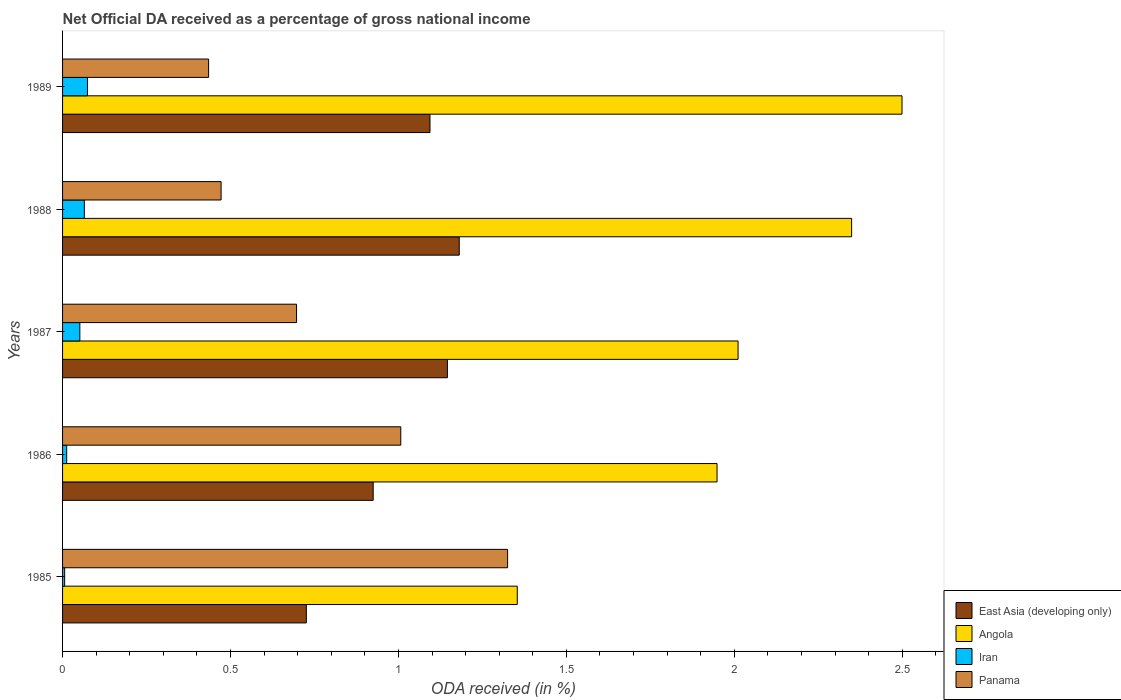How many different coloured bars are there?
Offer a very short reply. 4. Are the number of bars on each tick of the Y-axis equal?
Give a very brief answer. Yes. How many bars are there on the 5th tick from the top?
Your answer should be compact. 4. What is the net official DA received in East Asia (developing only) in 1987?
Your answer should be very brief. 1.15. Across all years, what is the maximum net official DA received in Iran?
Your answer should be very brief. 0.07. Across all years, what is the minimum net official DA received in Angola?
Offer a very short reply. 1.35. In which year was the net official DA received in Iran minimum?
Your answer should be compact. 1985. What is the total net official DA received in Iran in the graph?
Provide a succinct answer. 0.21. What is the difference between the net official DA received in Angola in 1985 and that in 1986?
Your answer should be very brief. -0.59. What is the difference between the net official DA received in East Asia (developing only) in 1987 and the net official DA received in Angola in 1985?
Offer a terse response. -0.21. What is the average net official DA received in Iran per year?
Give a very brief answer. 0.04. In the year 1986, what is the difference between the net official DA received in Panama and net official DA received in Iran?
Your answer should be very brief. 0.99. What is the ratio of the net official DA received in Iran in 1985 to that in 1988?
Ensure brevity in your answer.  0.1. Is the net official DA received in East Asia (developing only) in 1985 less than that in 1987?
Your answer should be very brief. Yes. What is the difference between the highest and the second highest net official DA received in East Asia (developing only)?
Ensure brevity in your answer.  0.04. What is the difference between the highest and the lowest net official DA received in Panama?
Make the answer very short. 0.89. Is the sum of the net official DA received in Iran in 1986 and 1987 greater than the maximum net official DA received in Panama across all years?
Your response must be concise. No. What does the 2nd bar from the top in 1987 represents?
Offer a very short reply. Iran. What does the 3rd bar from the bottom in 1988 represents?
Make the answer very short. Iran. How many years are there in the graph?
Your response must be concise. 5. What is the difference between two consecutive major ticks on the X-axis?
Provide a short and direct response. 0.5. Does the graph contain grids?
Offer a terse response. No. What is the title of the graph?
Your answer should be compact. Net Official DA received as a percentage of gross national income. What is the label or title of the X-axis?
Keep it short and to the point. ODA received (in %). What is the ODA received (in %) in East Asia (developing only) in 1985?
Your response must be concise. 0.73. What is the ODA received (in %) in Angola in 1985?
Your answer should be very brief. 1.35. What is the ODA received (in %) in Iran in 1985?
Give a very brief answer. 0.01. What is the ODA received (in %) of Panama in 1985?
Make the answer very short. 1.32. What is the ODA received (in %) in East Asia (developing only) in 1986?
Give a very brief answer. 0.92. What is the ODA received (in %) in Angola in 1986?
Offer a terse response. 1.95. What is the ODA received (in %) of Iran in 1986?
Provide a short and direct response. 0.01. What is the ODA received (in %) in Panama in 1986?
Offer a very short reply. 1.01. What is the ODA received (in %) of East Asia (developing only) in 1987?
Ensure brevity in your answer.  1.15. What is the ODA received (in %) of Angola in 1987?
Make the answer very short. 2.01. What is the ODA received (in %) in Iran in 1987?
Provide a succinct answer. 0.05. What is the ODA received (in %) of Panama in 1987?
Offer a very short reply. 0.7. What is the ODA received (in %) in East Asia (developing only) in 1988?
Keep it short and to the point. 1.18. What is the ODA received (in %) in Angola in 1988?
Make the answer very short. 2.35. What is the ODA received (in %) in Iran in 1988?
Offer a very short reply. 0.06. What is the ODA received (in %) of Panama in 1988?
Provide a succinct answer. 0.47. What is the ODA received (in %) in East Asia (developing only) in 1989?
Give a very brief answer. 1.09. What is the ODA received (in %) of Angola in 1989?
Your response must be concise. 2.5. What is the ODA received (in %) of Iran in 1989?
Offer a very short reply. 0.07. What is the ODA received (in %) of Panama in 1989?
Your response must be concise. 0.43. Across all years, what is the maximum ODA received (in %) of East Asia (developing only)?
Offer a terse response. 1.18. Across all years, what is the maximum ODA received (in %) of Angola?
Offer a very short reply. 2.5. Across all years, what is the maximum ODA received (in %) in Iran?
Ensure brevity in your answer.  0.07. Across all years, what is the maximum ODA received (in %) in Panama?
Offer a terse response. 1.32. Across all years, what is the minimum ODA received (in %) of East Asia (developing only)?
Offer a very short reply. 0.73. Across all years, what is the minimum ODA received (in %) in Angola?
Make the answer very short. 1.35. Across all years, what is the minimum ODA received (in %) in Iran?
Offer a very short reply. 0.01. Across all years, what is the minimum ODA received (in %) in Panama?
Provide a succinct answer. 0.43. What is the total ODA received (in %) in East Asia (developing only) in the graph?
Provide a succinct answer. 5.07. What is the total ODA received (in %) in Angola in the graph?
Your answer should be compact. 10.16. What is the total ODA received (in %) in Iran in the graph?
Provide a short and direct response. 0.21. What is the total ODA received (in %) in Panama in the graph?
Your answer should be very brief. 3.94. What is the difference between the ODA received (in %) in East Asia (developing only) in 1985 and that in 1986?
Give a very brief answer. -0.2. What is the difference between the ODA received (in %) in Angola in 1985 and that in 1986?
Offer a terse response. -0.59. What is the difference between the ODA received (in %) of Iran in 1985 and that in 1986?
Your answer should be very brief. -0.01. What is the difference between the ODA received (in %) in Panama in 1985 and that in 1986?
Make the answer very short. 0.32. What is the difference between the ODA received (in %) in East Asia (developing only) in 1985 and that in 1987?
Your answer should be very brief. -0.42. What is the difference between the ODA received (in %) in Angola in 1985 and that in 1987?
Keep it short and to the point. -0.66. What is the difference between the ODA received (in %) of Iran in 1985 and that in 1987?
Offer a very short reply. -0.05. What is the difference between the ODA received (in %) in Panama in 1985 and that in 1987?
Give a very brief answer. 0.63. What is the difference between the ODA received (in %) of East Asia (developing only) in 1985 and that in 1988?
Give a very brief answer. -0.46. What is the difference between the ODA received (in %) of Angola in 1985 and that in 1988?
Keep it short and to the point. -1. What is the difference between the ODA received (in %) in Iran in 1985 and that in 1988?
Provide a short and direct response. -0.06. What is the difference between the ODA received (in %) in Panama in 1985 and that in 1988?
Your answer should be compact. 0.85. What is the difference between the ODA received (in %) in East Asia (developing only) in 1985 and that in 1989?
Make the answer very short. -0.37. What is the difference between the ODA received (in %) of Angola in 1985 and that in 1989?
Provide a succinct answer. -1.15. What is the difference between the ODA received (in %) of Iran in 1985 and that in 1989?
Keep it short and to the point. -0.07. What is the difference between the ODA received (in %) of Panama in 1985 and that in 1989?
Provide a short and direct response. 0.89. What is the difference between the ODA received (in %) of East Asia (developing only) in 1986 and that in 1987?
Offer a very short reply. -0.22. What is the difference between the ODA received (in %) of Angola in 1986 and that in 1987?
Provide a succinct answer. -0.06. What is the difference between the ODA received (in %) in Iran in 1986 and that in 1987?
Make the answer very short. -0.04. What is the difference between the ODA received (in %) in Panama in 1986 and that in 1987?
Your answer should be very brief. 0.31. What is the difference between the ODA received (in %) of East Asia (developing only) in 1986 and that in 1988?
Offer a terse response. -0.26. What is the difference between the ODA received (in %) of Angola in 1986 and that in 1988?
Provide a succinct answer. -0.4. What is the difference between the ODA received (in %) in Iran in 1986 and that in 1988?
Keep it short and to the point. -0.05. What is the difference between the ODA received (in %) of Panama in 1986 and that in 1988?
Your answer should be compact. 0.53. What is the difference between the ODA received (in %) in East Asia (developing only) in 1986 and that in 1989?
Your answer should be compact. -0.17. What is the difference between the ODA received (in %) of Angola in 1986 and that in 1989?
Offer a very short reply. -0.55. What is the difference between the ODA received (in %) in Iran in 1986 and that in 1989?
Ensure brevity in your answer.  -0.06. What is the difference between the ODA received (in %) of Panama in 1986 and that in 1989?
Offer a terse response. 0.57. What is the difference between the ODA received (in %) in East Asia (developing only) in 1987 and that in 1988?
Ensure brevity in your answer.  -0.04. What is the difference between the ODA received (in %) in Angola in 1987 and that in 1988?
Your response must be concise. -0.34. What is the difference between the ODA received (in %) of Iran in 1987 and that in 1988?
Provide a short and direct response. -0.01. What is the difference between the ODA received (in %) in Panama in 1987 and that in 1988?
Your answer should be very brief. 0.22. What is the difference between the ODA received (in %) of East Asia (developing only) in 1987 and that in 1989?
Offer a very short reply. 0.05. What is the difference between the ODA received (in %) in Angola in 1987 and that in 1989?
Your answer should be very brief. -0.49. What is the difference between the ODA received (in %) in Iran in 1987 and that in 1989?
Your answer should be very brief. -0.02. What is the difference between the ODA received (in %) in Panama in 1987 and that in 1989?
Give a very brief answer. 0.26. What is the difference between the ODA received (in %) in East Asia (developing only) in 1988 and that in 1989?
Offer a very short reply. 0.09. What is the difference between the ODA received (in %) in Iran in 1988 and that in 1989?
Offer a terse response. -0.01. What is the difference between the ODA received (in %) in Panama in 1988 and that in 1989?
Offer a terse response. 0.04. What is the difference between the ODA received (in %) of East Asia (developing only) in 1985 and the ODA received (in %) of Angola in 1986?
Offer a very short reply. -1.22. What is the difference between the ODA received (in %) in East Asia (developing only) in 1985 and the ODA received (in %) in Iran in 1986?
Offer a terse response. 0.71. What is the difference between the ODA received (in %) of East Asia (developing only) in 1985 and the ODA received (in %) of Panama in 1986?
Your answer should be compact. -0.28. What is the difference between the ODA received (in %) of Angola in 1985 and the ODA received (in %) of Iran in 1986?
Make the answer very short. 1.34. What is the difference between the ODA received (in %) in Angola in 1985 and the ODA received (in %) in Panama in 1986?
Give a very brief answer. 0.35. What is the difference between the ODA received (in %) in Iran in 1985 and the ODA received (in %) in Panama in 1986?
Give a very brief answer. -1. What is the difference between the ODA received (in %) of East Asia (developing only) in 1985 and the ODA received (in %) of Angola in 1987?
Give a very brief answer. -1.29. What is the difference between the ODA received (in %) in East Asia (developing only) in 1985 and the ODA received (in %) in Iran in 1987?
Provide a succinct answer. 0.67. What is the difference between the ODA received (in %) in East Asia (developing only) in 1985 and the ODA received (in %) in Panama in 1987?
Offer a terse response. 0.03. What is the difference between the ODA received (in %) of Angola in 1985 and the ODA received (in %) of Iran in 1987?
Give a very brief answer. 1.3. What is the difference between the ODA received (in %) in Angola in 1985 and the ODA received (in %) in Panama in 1987?
Your response must be concise. 0.66. What is the difference between the ODA received (in %) in Iran in 1985 and the ODA received (in %) in Panama in 1987?
Give a very brief answer. -0.69. What is the difference between the ODA received (in %) in East Asia (developing only) in 1985 and the ODA received (in %) in Angola in 1988?
Your response must be concise. -1.62. What is the difference between the ODA received (in %) of East Asia (developing only) in 1985 and the ODA received (in %) of Iran in 1988?
Provide a succinct answer. 0.66. What is the difference between the ODA received (in %) in East Asia (developing only) in 1985 and the ODA received (in %) in Panama in 1988?
Your answer should be very brief. 0.25. What is the difference between the ODA received (in %) in Angola in 1985 and the ODA received (in %) in Iran in 1988?
Make the answer very short. 1.29. What is the difference between the ODA received (in %) of Angola in 1985 and the ODA received (in %) of Panama in 1988?
Offer a very short reply. 0.88. What is the difference between the ODA received (in %) in Iran in 1985 and the ODA received (in %) in Panama in 1988?
Provide a succinct answer. -0.47. What is the difference between the ODA received (in %) in East Asia (developing only) in 1985 and the ODA received (in %) in Angola in 1989?
Your answer should be very brief. -1.77. What is the difference between the ODA received (in %) of East Asia (developing only) in 1985 and the ODA received (in %) of Iran in 1989?
Offer a terse response. 0.65. What is the difference between the ODA received (in %) in East Asia (developing only) in 1985 and the ODA received (in %) in Panama in 1989?
Offer a terse response. 0.29. What is the difference between the ODA received (in %) in Angola in 1985 and the ODA received (in %) in Iran in 1989?
Offer a terse response. 1.28. What is the difference between the ODA received (in %) in Angola in 1985 and the ODA received (in %) in Panama in 1989?
Your response must be concise. 0.92. What is the difference between the ODA received (in %) of Iran in 1985 and the ODA received (in %) of Panama in 1989?
Offer a very short reply. -0.43. What is the difference between the ODA received (in %) of East Asia (developing only) in 1986 and the ODA received (in %) of Angola in 1987?
Offer a terse response. -1.09. What is the difference between the ODA received (in %) of East Asia (developing only) in 1986 and the ODA received (in %) of Iran in 1987?
Your response must be concise. 0.87. What is the difference between the ODA received (in %) in East Asia (developing only) in 1986 and the ODA received (in %) in Panama in 1987?
Ensure brevity in your answer.  0.23. What is the difference between the ODA received (in %) of Angola in 1986 and the ODA received (in %) of Iran in 1987?
Provide a short and direct response. 1.9. What is the difference between the ODA received (in %) of Angola in 1986 and the ODA received (in %) of Panama in 1987?
Keep it short and to the point. 1.25. What is the difference between the ODA received (in %) of Iran in 1986 and the ODA received (in %) of Panama in 1987?
Your answer should be compact. -0.68. What is the difference between the ODA received (in %) of East Asia (developing only) in 1986 and the ODA received (in %) of Angola in 1988?
Keep it short and to the point. -1.42. What is the difference between the ODA received (in %) in East Asia (developing only) in 1986 and the ODA received (in %) in Iran in 1988?
Your response must be concise. 0.86. What is the difference between the ODA received (in %) in East Asia (developing only) in 1986 and the ODA received (in %) in Panama in 1988?
Your answer should be compact. 0.45. What is the difference between the ODA received (in %) of Angola in 1986 and the ODA received (in %) of Iran in 1988?
Make the answer very short. 1.88. What is the difference between the ODA received (in %) of Angola in 1986 and the ODA received (in %) of Panama in 1988?
Offer a terse response. 1.48. What is the difference between the ODA received (in %) of Iran in 1986 and the ODA received (in %) of Panama in 1988?
Give a very brief answer. -0.46. What is the difference between the ODA received (in %) of East Asia (developing only) in 1986 and the ODA received (in %) of Angola in 1989?
Your response must be concise. -1.57. What is the difference between the ODA received (in %) of East Asia (developing only) in 1986 and the ODA received (in %) of Iran in 1989?
Offer a terse response. 0.85. What is the difference between the ODA received (in %) in East Asia (developing only) in 1986 and the ODA received (in %) in Panama in 1989?
Give a very brief answer. 0.49. What is the difference between the ODA received (in %) of Angola in 1986 and the ODA received (in %) of Iran in 1989?
Offer a very short reply. 1.87. What is the difference between the ODA received (in %) of Angola in 1986 and the ODA received (in %) of Panama in 1989?
Your answer should be compact. 1.51. What is the difference between the ODA received (in %) of Iran in 1986 and the ODA received (in %) of Panama in 1989?
Give a very brief answer. -0.42. What is the difference between the ODA received (in %) in East Asia (developing only) in 1987 and the ODA received (in %) in Angola in 1988?
Your answer should be compact. -1.2. What is the difference between the ODA received (in %) of East Asia (developing only) in 1987 and the ODA received (in %) of Iran in 1988?
Your response must be concise. 1.08. What is the difference between the ODA received (in %) in East Asia (developing only) in 1987 and the ODA received (in %) in Panama in 1988?
Your response must be concise. 0.67. What is the difference between the ODA received (in %) in Angola in 1987 and the ODA received (in %) in Iran in 1988?
Provide a short and direct response. 1.95. What is the difference between the ODA received (in %) of Angola in 1987 and the ODA received (in %) of Panama in 1988?
Provide a succinct answer. 1.54. What is the difference between the ODA received (in %) in Iran in 1987 and the ODA received (in %) in Panama in 1988?
Provide a short and direct response. -0.42. What is the difference between the ODA received (in %) of East Asia (developing only) in 1987 and the ODA received (in %) of Angola in 1989?
Provide a short and direct response. -1.35. What is the difference between the ODA received (in %) in East Asia (developing only) in 1987 and the ODA received (in %) in Iran in 1989?
Provide a short and direct response. 1.07. What is the difference between the ODA received (in %) in East Asia (developing only) in 1987 and the ODA received (in %) in Panama in 1989?
Offer a terse response. 0.71. What is the difference between the ODA received (in %) of Angola in 1987 and the ODA received (in %) of Iran in 1989?
Provide a succinct answer. 1.94. What is the difference between the ODA received (in %) in Angola in 1987 and the ODA received (in %) in Panama in 1989?
Offer a very short reply. 1.58. What is the difference between the ODA received (in %) of Iran in 1987 and the ODA received (in %) of Panama in 1989?
Ensure brevity in your answer.  -0.38. What is the difference between the ODA received (in %) in East Asia (developing only) in 1988 and the ODA received (in %) in Angola in 1989?
Your answer should be very brief. -1.32. What is the difference between the ODA received (in %) of East Asia (developing only) in 1988 and the ODA received (in %) of Iran in 1989?
Make the answer very short. 1.11. What is the difference between the ODA received (in %) in East Asia (developing only) in 1988 and the ODA received (in %) in Panama in 1989?
Provide a succinct answer. 0.75. What is the difference between the ODA received (in %) of Angola in 1988 and the ODA received (in %) of Iran in 1989?
Give a very brief answer. 2.27. What is the difference between the ODA received (in %) of Angola in 1988 and the ODA received (in %) of Panama in 1989?
Ensure brevity in your answer.  1.91. What is the difference between the ODA received (in %) of Iran in 1988 and the ODA received (in %) of Panama in 1989?
Provide a short and direct response. -0.37. What is the average ODA received (in %) of East Asia (developing only) per year?
Provide a succinct answer. 1.01. What is the average ODA received (in %) of Angola per year?
Your answer should be very brief. 2.03. What is the average ODA received (in %) of Iran per year?
Make the answer very short. 0.04. What is the average ODA received (in %) in Panama per year?
Ensure brevity in your answer.  0.79. In the year 1985, what is the difference between the ODA received (in %) in East Asia (developing only) and ODA received (in %) in Angola?
Your answer should be compact. -0.63. In the year 1985, what is the difference between the ODA received (in %) of East Asia (developing only) and ODA received (in %) of Iran?
Your answer should be compact. 0.72. In the year 1985, what is the difference between the ODA received (in %) of East Asia (developing only) and ODA received (in %) of Panama?
Offer a very short reply. -0.6. In the year 1985, what is the difference between the ODA received (in %) of Angola and ODA received (in %) of Iran?
Offer a terse response. 1.35. In the year 1985, what is the difference between the ODA received (in %) of Angola and ODA received (in %) of Panama?
Provide a short and direct response. 0.03. In the year 1985, what is the difference between the ODA received (in %) of Iran and ODA received (in %) of Panama?
Provide a short and direct response. -1.32. In the year 1986, what is the difference between the ODA received (in %) in East Asia (developing only) and ODA received (in %) in Angola?
Provide a succinct answer. -1.02. In the year 1986, what is the difference between the ODA received (in %) in East Asia (developing only) and ODA received (in %) in Iran?
Your answer should be compact. 0.91. In the year 1986, what is the difference between the ODA received (in %) of East Asia (developing only) and ODA received (in %) of Panama?
Your answer should be compact. -0.08. In the year 1986, what is the difference between the ODA received (in %) in Angola and ODA received (in %) in Iran?
Your answer should be very brief. 1.94. In the year 1986, what is the difference between the ODA received (in %) of Angola and ODA received (in %) of Panama?
Make the answer very short. 0.94. In the year 1986, what is the difference between the ODA received (in %) of Iran and ODA received (in %) of Panama?
Offer a very short reply. -0.99. In the year 1987, what is the difference between the ODA received (in %) of East Asia (developing only) and ODA received (in %) of Angola?
Your answer should be very brief. -0.87. In the year 1987, what is the difference between the ODA received (in %) of East Asia (developing only) and ODA received (in %) of Iran?
Your response must be concise. 1.09. In the year 1987, what is the difference between the ODA received (in %) of East Asia (developing only) and ODA received (in %) of Panama?
Your response must be concise. 0.45. In the year 1987, what is the difference between the ODA received (in %) in Angola and ODA received (in %) in Iran?
Offer a terse response. 1.96. In the year 1987, what is the difference between the ODA received (in %) of Angola and ODA received (in %) of Panama?
Make the answer very short. 1.31. In the year 1987, what is the difference between the ODA received (in %) of Iran and ODA received (in %) of Panama?
Provide a succinct answer. -0.65. In the year 1988, what is the difference between the ODA received (in %) of East Asia (developing only) and ODA received (in %) of Angola?
Ensure brevity in your answer.  -1.17. In the year 1988, what is the difference between the ODA received (in %) of East Asia (developing only) and ODA received (in %) of Iran?
Keep it short and to the point. 1.12. In the year 1988, what is the difference between the ODA received (in %) of East Asia (developing only) and ODA received (in %) of Panama?
Give a very brief answer. 0.71. In the year 1988, what is the difference between the ODA received (in %) in Angola and ODA received (in %) in Iran?
Offer a very short reply. 2.28. In the year 1988, what is the difference between the ODA received (in %) in Angola and ODA received (in %) in Panama?
Make the answer very short. 1.88. In the year 1988, what is the difference between the ODA received (in %) of Iran and ODA received (in %) of Panama?
Make the answer very short. -0.41. In the year 1989, what is the difference between the ODA received (in %) in East Asia (developing only) and ODA received (in %) in Angola?
Provide a short and direct response. -1.41. In the year 1989, what is the difference between the ODA received (in %) of East Asia (developing only) and ODA received (in %) of Iran?
Your answer should be very brief. 1.02. In the year 1989, what is the difference between the ODA received (in %) in East Asia (developing only) and ODA received (in %) in Panama?
Your answer should be very brief. 0.66. In the year 1989, what is the difference between the ODA received (in %) of Angola and ODA received (in %) of Iran?
Provide a short and direct response. 2.43. In the year 1989, what is the difference between the ODA received (in %) of Angola and ODA received (in %) of Panama?
Your answer should be very brief. 2.06. In the year 1989, what is the difference between the ODA received (in %) of Iran and ODA received (in %) of Panama?
Your answer should be very brief. -0.36. What is the ratio of the ODA received (in %) in East Asia (developing only) in 1985 to that in 1986?
Offer a very short reply. 0.78. What is the ratio of the ODA received (in %) in Angola in 1985 to that in 1986?
Provide a succinct answer. 0.69. What is the ratio of the ODA received (in %) of Iran in 1985 to that in 1986?
Give a very brief answer. 0.51. What is the ratio of the ODA received (in %) in Panama in 1985 to that in 1986?
Keep it short and to the point. 1.32. What is the ratio of the ODA received (in %) of East Asia (developing only) in 1985 to that in 1987?
Your answer should be compact. 0.63. What is the ratio of the ODA received (in %) in Angola in 1985 to that in 1987?
Provide a short and direct response. 0.67. What is the ratio of the ODA received (in %) of Iran in 1985 to that in 1987?
Provide a short and direct response. 0.12. What is the ratio of the ODA received (in %) in Panama in 1985 to that in 1987?
Provide a short and direct response. 1.9. What is the ratio of the ODA received (in %) in East Asia (developing only) in 1985 to that in 1988?
Offer a terse response. 0.61. What is the ratio of the ODA received (in %) in Angola in 1985 to that in 1988?
Give a very brief answer. 0.58. What is the ratio of the ODA received (in %) of Iran in 1985 to that in 1988?
Your response must be concise. 0.1. What is the ratio of the ODA received (in %) of Panama in 1985 to that in 1988?
Offer a very short reply. 2.81. What is the ratio of the ODA received (in %) in East Asia (developing only) in 1985 to that in 1989?
Your response must be concise. 0.66. What is the ratio of the ODA received (in %) in Angola in 1985 to that in 1989?
Ensure brevity in your answer.  0.54. What is the ratio of the ODA received (in %) in Iran in 1985 to that in 1989?
Keep it short and to the point. 0.08. What is the ratio of the ODA received (in %) of Panama in 1985 to that in 1989?
Provide a short and direct response. 3.05. What is the ratio of the ODA received (in %) in East Asia (developing only) in 1986 to that in 1987?
Ensure brevity in your answer.  0.81. What is the ratio of the ODA received (in %) in Angola in 1986 to that in 1987?
Offer a very short reply. 0.97. What is the ratio of the ODA received (in %) of Iran in 1986 to that in 1987?
Offer a very short reply. 0.24. What is the ratio of the ODA received (in %) of Panama in 1986 to that in 1987?
Ensure brevity in your answer.  1.45. What is the ratio of the ODA received (in %) in East Asia (developing only) in 1986 to that in 1988?
Ensure brevity in your answer.  0.78. What is the ratio of the ODA received (in %) of Angola in 1986 to that in 1988?
Your answer should be compact. 0.83. What is the ratio of the ODA received (in %) of Iran in 1986 to that in 1988?
Offer a very short reply. 0.19. What is the ratio of the ODA received (in %) of Panama in 1986 to that in 1988?
Offer a very short reply. 2.13. What is the ratio of the ODA received (in %) in East Asia (developing only) in 1986 to that in 1989?
Offer a terse response. 0.85. What is the ratio of the ODA received (in %) in Angola in 1986 to that in 1989?
Ensure brevity in your answer.  0.78. What is the ratio of the ODA received (in %) of Iran in 1986 to that in 1989?
Your answer should be very brief. 0.17. What is the ratio of the ODA received (in %) of Panama in 1986 to that in 1989?
Your answer should be compact. 2.32. What is the ratio of the ODA received (in %) of East Asia (developing only) in 1987 to that in 1988?
Offer a terse response. 0.97. What is the ratio of the ODA received (in %) of Angola in 1987 to that in 1988?
Offer a very short reply. 0.86. What is the ratio of the ODA received (in %) in Iran in 1987 to that in 1988?
Offer a terse response. 0.79. What is the ratio of the ODA received (in %) of Panama in 1987 to that in 1988?
Your answer should be compact. 1.48. What is the ratio of the ODA received (in %) in East Asia (developing only) in 1987 to that in 1989?
Your answer should be compact. 1.05. What is the ratio of the ODA received (in %) in Angola in 1987 to that in 1989?
Ensure brevity in your answer.  0.8. What is the ratio of the ODA received (in %) of Iran in 1987 to that in 1989?
Your response must be concise. 0.69. What is the ratio of the ODA received (in %) of Panama in 1987 to that in 1989?
Your response must be concise. 1.6. What is the ratio of the ODA received (in %) in East Asia (developing only) in 1988 to that in 1989?
Make the answer very short. 1.08. What is the ratio of the ODA received (in %) of Angola in 1988 to that in 1989?
Ensure brevity in your answer.  0.94. What is the ratio of the ODA received (in %) of Iran in 1988 to that in 1989?
Keep it short and to the point. 0.87. What is the ratio of the ODA received (in %) in Panama in 1988 to that in 1989?
Keep it short and to the point. 1.09. What is the difference between the highest and the second highest ODA received (in %) of East Asia (developing only)?
Keep it short and to the point. 0.04. What is the difference between the highest and the second highest ODA received (in %) of Angola?
Keep it short and to the point. 0.15. What is the difference between the highest and the second highest ODA received (in %) of Iran?
Give a very brief answer. 0.01. What is the difference between the highest and the second highest ODA received (in %) in Panama?
Your answer should be very brief. 0.32. What is the difference between the highest and the lowest ODA received (in %) of East Asia (developing only)?
Make the answer very short. 0.46. What is the difference between the highest and the lowest ODA received (in %) of Angola?
Your answer should be compact. 1.15. What is the difference between the highest and the lowest ODA received (in %) of Iran?
Provide a short and direct response. 0.07. What is the difference between the highest and the lowest ODA received (in %) of Panama?
Make the answer very short. 0.89. 